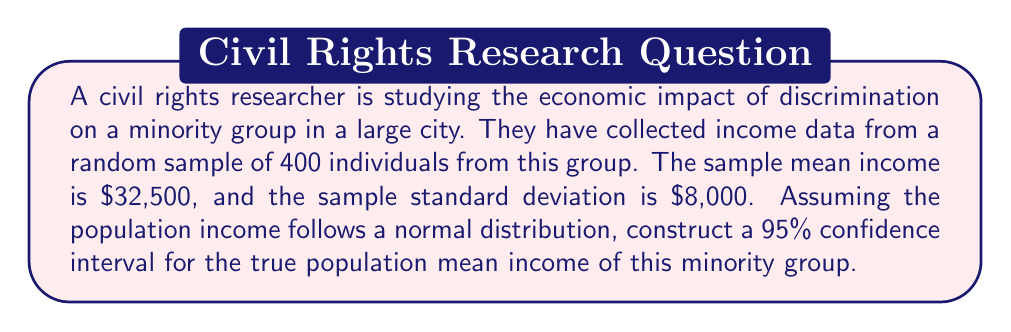Help me with this question. To construct a 95% confidence interval for the population mean, we'll use the formula:

$$ \bar{x} \pm t_{\alpha/2, n-1} \cdot \frac{s}{\sqrt{n}} $$

Where:
- $\bar{x}$ is the sample mean
- $t_{\alpha/2, n-1}$ is the t-value for a 95% confidence level with n-1 degrees of freedom
- $s$ is the sample standard deviation
- $n$ is the sample size

Step 1: Identify the known values
- $\bar{x} = 32,500$
- $s = 8,000$
- $n = 400$
- Confidence level = 95% (α = 0.05)

Step 2: Find the t-value
With 399 degrees of freedom (n-1) and α/2 = 0.025, the t-value is approximately 1.966 (using t-distribution table or calculator).

Step 3: Calculate the margin of error
$$ \text{Margin of Error} = t_{\alpha/2, n-1} \cdot \frac{s}{\sqrt{n}} = 1.966 \cdot \frac{8,000}{\sqrt{400}} \approx 784.33 $$

Step 4: Calculate the confidence interval
Lower bound: $32,500 - 784.33 = 31,715.67$
Upper bound: $32,500 + 784.33 = 33,284.33$

Therefore, the 95% confidence interval for the true population mean income is ($31,715.67, $33,284.33).
Answer: ($31,715.67, $33,284.33) 